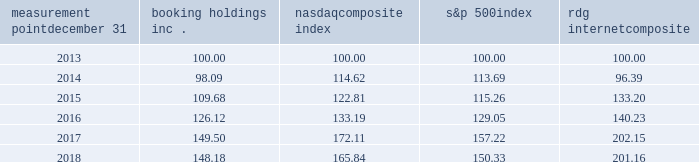Measurement point december 31 booking holdings nasdaq composite index s&p 500 rdg internet composite .

What was the percentage change in booking holding inc . for the five years ended 2018? 
Computations: ((148.18 - 100) / 100)
Answer: 0.4818. 